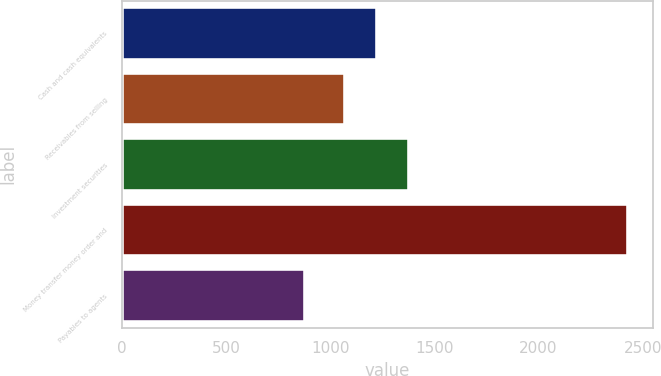Convert chart to OTSL. <chart><loc_0><loc_0><loc_500><loc_500><bar_chart><fcel>Cash and cash equivalents<fcel>Receivables from selling<fcel>Investment securities<fcel>Money transfer money order and<fcel>Payables to agents<nl><fcel>1225.23<fcel>1070.4<fcel>1380.06<fcel>2428.5<fcel>880.2<nl></chart> 